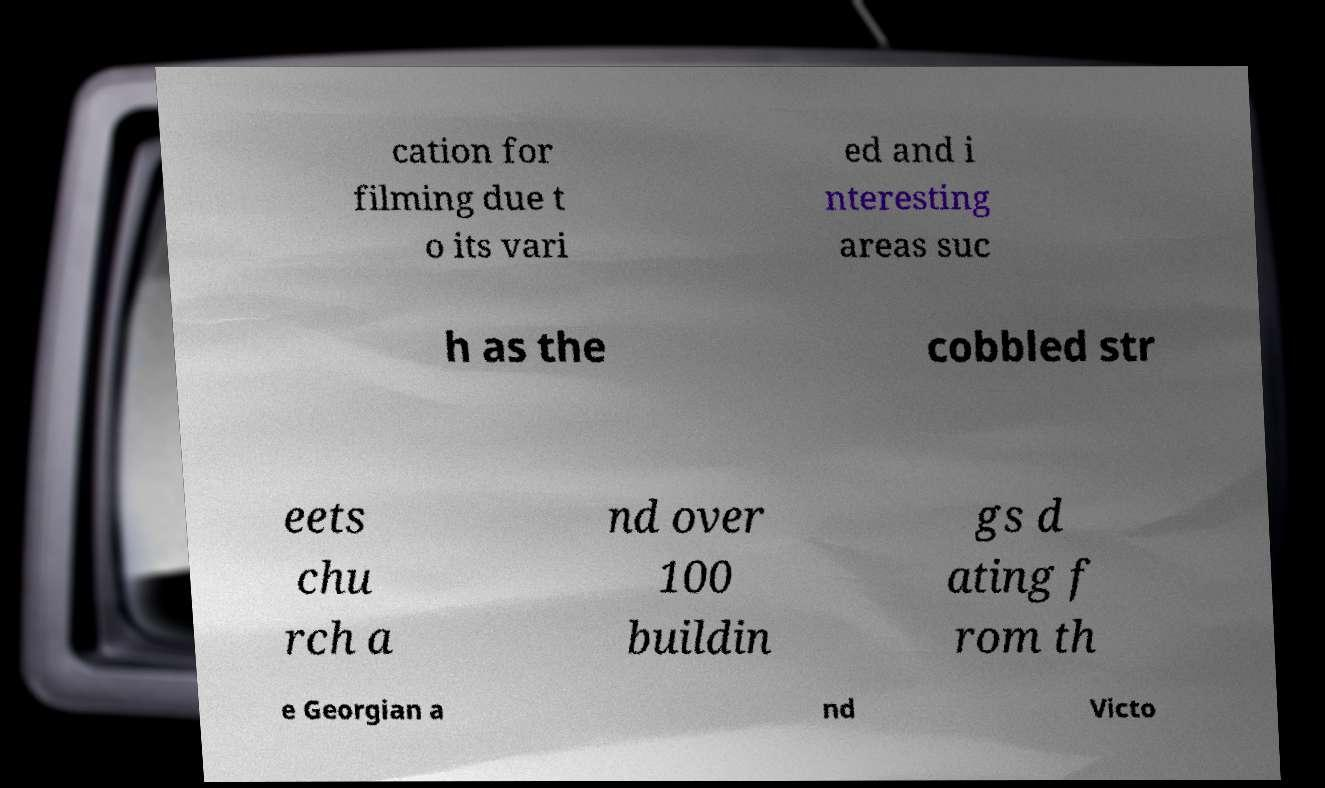There's text embedded in this image that I need extracted. Can you transcribe it verbatim? cation for filming due t o its vari ed and i nteresting areas suc h as the cobbled str eets chu rch a nd over 100 buildin gs d ating f rom th e Georgian a nd Victo 